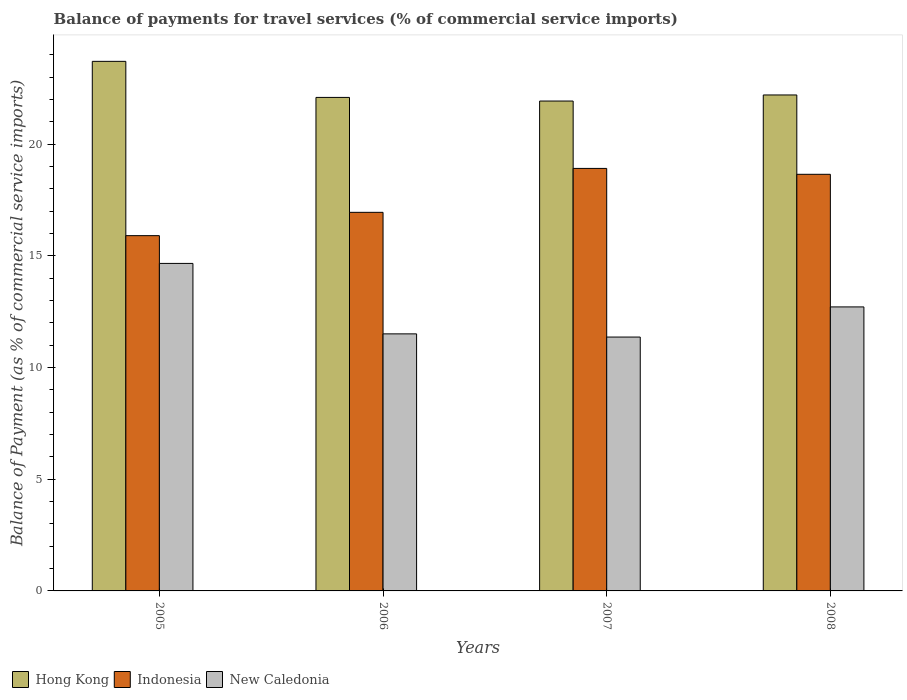How many different coloured bars are there?
Make the answer very short. 3. How many groups of bars are there?
Provide a succinct answer. 4. Are the number of bars per tick equal to the number of legend labels?
Provide a short and direct response. Yes. Are the number of bars on each tick of the X-axis equal?
Offer a very short reply. Yes. What is the label of the 1st group of bars from the left?
Give a very brief answer. 2005. In how many cases, is the number of bars for a given year not equal to the number of legend labels?
Give a very brief answer. 0. What is the balance of payments for travel services in Indonesia in 2005?
Your answer should be very brief. 15.91. Across all years, what is the maximum balance of payments for travel services in Hong Kong?
Your answer should be compact. 23.71. Across all years, what is the minimum balance of payments for travel services in Indonesia?
Offer a very short reply. 15.91. In which year was the balance of payments for travel services in Hong Kong maximum?
Your response must be concise. 2005. What is the total balance of payments for travel services in Indonesia in the graph?
Make the answer very short. 70.43. What is the difference between the balance of payments for travel services in Indonesia in 2005 and that in 2007?
Keep it short and to the point. -3.01. What is the difference between the balance of payments for travel services in New Caledonia in 2008 and the balance of payments for travel services in Indonesia in 2007?
Make the answer very short. -6.2. What is the average balance of payments for travel services in New Caledonia per year?
Your answer should be compact. 12.56. In the year 2008, what is the difference between the balance of payments for travel services in New Caledonia and balance of payments for travel services in Indonesia?
Your answer should be very brief. -5.94. What is the ratio of the balance of payments for travel services in Hong Kong in 2007 to that in 2008?
Offer a very short reply. 0.99. Is the balance of payments for travel services in Indonesia in 2006 less than that in 2008?
Ensure brevity in your answer.  Yes. What is the difference between the highest and the second highest balance of payments for travel services in Hong Kong?
Your answer should be very brief. 1.5. What is the difference between the highest and the lowest balance of payments for travel services in Indonesia?
Give a very brief answer. 3.01. In how many years, is the balance of payments for travel services in New Caledonia greater than the average balance of payments for travel services in New Caledonia taken over all years?
Provide a succinct answer. 2. What does the 2nd bar from the left in 2005 represents?
Offer a terse response. Indonesia. What does the 3rd bar from the right in 2008 represents?
Your answer should be compact. Hong Kong. Is it the case that in every year, the sum of the balance of payments for travel services in Indonesia and balance of payments for travel services in Hong Kong is greater than the balance of payments for travel services in New Caledonia?
Your answer should be very brief. Yes. What is the difference between two consecutive major ticks on the Y-axis?
Provide a succinct answer. 5. Are the values on the major ticks of Y-axis written in scientific E-notation?
Your answer should be very brief. No. Does the graph contain any zero values?
Keep it short and to the point. No. How many legend labels are there?
Your response must be concise. 3. How are the legend labels stacked?
Offer a terse response. Horizontal. What is the title of the graph?
Your answer should be compact. Balance of payments for travel services (% of commercial service imports). What is the label or title of the Y-axis?
Offer a terse response. Balance of Payment (as % of commercial service imports). What is the Balance of Payment (as % of commercial service imports) in Hong Kong in 2005?
Ensure brevity in your answer.  23.71. What is the Balance of Payment (as % of commercial service imports) in Indonesia in 2005?
Your answer should be very brief. 15.91. What is the Balance of Payment (as % of commercial service imports) in New Caledonia in 2005?
Your answer should be very brief. 14.66. What is the Balance of Payment (as % of commercial service imports) of Hong Kong in 2006?
Your answer should be compact. 22.1. What is the Balance of Payment (as % of commercial service imports) in Indonesia in 2006?
Your response must be concise. 16.95. What is the Balance of Payment (as % of commercial service imports) of New Caledonia in 2006?
Keep it short and to the point. 11.51. What is the Balance of Payment (as % of commercial service imports) of Hong Kong in 2007?
Offer a terse response. 21.93. What is the Balance of Payment (as % of commercial service imports) in Indonesia in 2007?
Your response must be concise. 18.92. What is the Balance of Payment (as % of commercial service imports) in New Caledonia in 2007?
Offer a very short reply. 11.37. What is the Balance of Payment (as % of commercial service imports) in Hong Kong in 2008?
Your response must be concise. 22.21. What is the Balance of Payment (as % of commercial service imports) of Indonesia in 2008?
Offer a very short reply. 18.65. What is the Balance of Payment (as % of commercial service imports) in New Caledonia in 2008?
Offer a very short reply. 12.72. Across all years, what is the maximum Balance of Payment (as % of commercial service imports) in Hong Kong?
Give a very brief answer. 23.71. Across all years, what is the maximum Balance of Payment (as % of commercial service imports) of Indonesia?
Offer a very short reply. 18.92. Across all years, what is the maximum Balance of Payment (as % of commercial service imports) in New Caledonia?
Your answer should be very brief. 14.66. Across all years, what is the minimum Balance of Payment (as % of commercial service imports) in Hong Kong?
Provide a succinct answer. 21.93. Across all years, what is the minimum Balance of Payment (as % of commercial service imports) of Indonesia?
Offer a very short reply. 15.91. Across all years, what is the minimum Balance of Payment (as % of commercial service imports) of New Caledonia?
Give a very brief answer. 11.37. What is the total Balance of Payment (as % of commercial service imports) in Hong Kong in the graph?
Offer a very short reply. 89.95. What is the total Balance of Payment (as % of commercial service imports) in Indonesia in the graph?
Your answer should be compact. 70.43. What is the total Balance of Payment (as % of commercial service imports) of New Caledonia in the graph?
Provide a short and direct response. 50.26. What is the difference between the Balance of Payment (as % of commercial service imports) in Hong Kong in 2005 and that in 2006?
Provide a short and direct response. 1.61. What is the difference between the Balance of Payment (as % of commercial service imports) in Indonesia in 2005 and that in 2006?
Provide a succinct answer. -1.04. What is the difference between the Balance of Payment (as % of commercial service imports) in New Caledonia in 2005 and that in 2006?
Your response must be concise. 3.16. What is the difference between the Balance of Payment (as % of commercial service imports) in Hong Kong in 2005 and that in 2007?
Your response must be concise. 1.78. What is the difference between the Balance of Payment (as % of commercial service imports) in Indonesia in 2005 and that in 2007?
Your response must be concise. -3.01. What is the difference between the Balance of Payment (as % of commercial service imports) of New Caledonia in 2005 and that in 2007?
Make the answer very short. 3.3. What is the difference between the Balance of Payment (as % of commercial service imports) of Hong Kong in 2005 and that in 2008?
Provide a short and direct response. 1.5. What is the difference between the Balance of Payment (as % of commercial service imports) in Indonesia in 2005 and that in 2008?
Provide a short and direct response. -2.75. What is the difference between the Balance of Payment (as % of commercial service imports) in New Caledonia in 2005 and that in 2008?
Ensure brevity in your answer.  1.95. What is the difference between the Balance of Payment (as % of commercial service imports) in Hong Kong in 2006 and that in 2007?
Your answer should be very brief. 0.16. What is the difference between the Balance of Payment (as % of commercial service imports) of Indonesia in 2006 and that in 2007?
Offer a terse response. -1.97. What is the difference between the Balance of Payment (as % of commercial service imports) of New Caledonia in 2006 and that in 2007?
Your response must be concise. 0.14. What is the difference between the Balance of Payment (as % of commercial service imports) in Hong Kong in 2006 and that in 2008?
Your answer should be very brief. -0.11. What is the difference between the Balance of Payment (as % of commercial service imports) of Indonesia in 2006 and that in 2008?
Your answer should be compact. -1.7. What is the difference between the Balance of Payment (as % of commercial service imports) in New Caledonia in 2006 and that in 2008?
Provide a short and direct response. -1.21. What is the difference between the Balance of Payment (as % of commercial service imports) in Hong Kong in 2007 and that in 2008?
Keep it short and to the point. -0.27. What is the difference between the Balance of Payment (as % of commercial service imports) in Indonesia in 2007 and that in 2008?
Your response must be concise. 0.26. What is the difference between the Balance of Payment (as % of commercial service imports) of New Caledonia in 2007 and that in 2008?
Your answer should be very brief. -1.35. What is the difference between the Balance of Payment (as % of commercial service imports) in Hong Kong in 2005 and the Balance of Payment (as % of commercial service imports) in Indonesia in 2006?
Keep it short and to the point. 6.76. What is the difference between the Balance of Payment (as % of commercial service imports) of Hong Kong in 2005 and the Balance of Payment (as % of commercial service imports) of New Caledonia in 2006?
Your response must be concise. 12.2. What is the difference between the Balance of Payment (as % of commercial service imports) of Indonesia in 2005 and the Balance of Payment (as % of commercial service imports) of New Caledonia in 2006?
Your answer should be very brief. 4.4. What is the difference between the Balance of Payment (as % of commercial service imports) of Hong Kong in 2005 and the Balance of Payment (as % of commercial service imports) of Indonesia in 2007?
Make the answer very short. 4.79. What is the difference between the Balance of Payment (as % of commercial service imports) in Hong Kong in 2005 and the Balance of Payment (as % of commercial service imports) in New Caledonia in 2007?
Keep it short and to the point. 12.34. What is the difference between the Balance of Payment (as % of commercial service imports) in Indonesia in 2005 and the Balance of Payment (as % of commercial service imports) in New Caledonia in 2007?
Keep it short and to the point. 4.54. What is the difference between the Balance of Payment (as % of commercial service imports) in Hong Kong in 2005 and the Balance of Payment (as % of commercial service imports) in Indonesia in 2008?
Your response must be concise. 5.06. What is the difference between the Balance of Payment (as % of commercial service imports) in Hong Kong in 2005 and the Balance of Payment (as % of commercial service imports) in New Caledonia in 2008?
Offer a very short reply. 11. What is the difference between the Balance of Payment (as % of commercial service imports) of Indonesia in 2005 and the Balance of Payment (as % of commercial service imports) of New Caledonia in 2008?
Provide a short and direct response. 3.19. What is the difference between the Balance of Payment (as % of commercial service imports) of Hong Kong in 2006 and the Balance of Payment (as % of commercial service imports) of Indonesia in 2007?
Offer a very short reply. 3.18. What is the difference between the Balance of Payment (as % of commercial service imports) of Hong Kong in 2006 and the Balance of Payment (as % of commercial service imports) of New Caledonia in 2007?
Your answer should be compact. 10.73. What is the difference between the Balance of Payment (as % of commercial service imports) in Indonesia in 2006 and the Balance of Payment (as % of commercial service imports) in New Caledonia in 2007?
Your answer should be compact. 5.58. What is the difference between the Balance of Payment (as % of commercial service imports) of Hong Kong in 2006 and the Balance of Payment (as % of commercial service imports) of Indonesia in 2008?
Make the answer very short. 3.44. What is the difference between the Balance of Payment (as % of commercial service imports) of Hong Kong in 2006 and the Balance of Payment (as % of commercial service imports) of New Caledonia in 2008?
Your answer should be compact. 9.38. What is the difference between the Balance of Payment (as % of commercial service imports) of Indonesia in 2006 and the Balance of Payment (as % of commercial service imports) of New Caledonia in 2008?
Provide a succinct answer. 4.23. What is the difference between the Balance of Payment (as % of commercial service imports) in Hong Kong in 2007 and the Balance of Payment (as % of commercial service imports) in Indonesia in 2008?
Ensure brevity in your answer.  3.28. What is the difference between the Balance of Payment (as % of commercial service imports) of Hong Kong in 2007 and the Balance of Payment (as % of commercial service imports) of New Caledonia in 2008?
Make the answer very short. 9.22. What is the difference between the Balance of Payment (as % of commercial service imports) of Indonesia in 2007 and the Balance of Payment (as % of commercial service imports) of New Caledonia in 2008?
Ensure brevity in your answer.  6.2. What is the average Balance of Payment (as % of commercial service imports) in Hong Kong per year?
Your answer should be compact. 22.49. What is the average Balance of Payment (as % of commercial service imports) in Indonesia per year?
Your response must be concise. 17.61. What is the average Balance of Payment (as % of commercial service imports) of New Caledonia per year?
Offer a very short reply. 12.56. In the year 2005, what is the difference between the Balance of Payment (as % of commercial service imports) of Hong Kong and Balance of Payment (as % of commercial service imports) of Indonesia?
Your answer should be very brief. 7.8. In the year 2005, what is the difference between the Balance of Payment (as % of commercial service imports) in Hong Kong and Balance of Payment (as % of commercial service imports) in New Caledonia?
Give a very brief answer. 9.05. In the year 2005, what is the difference between the Balance of Payment (as % of commercial service imports) of Indonesia and Balance of Payment (as % of commercial service imports) of New Caledonia?
Offer a terse response. 1.24. In the year 2006, what is the difference between the Balance of Payment (as % of commercial service imports) of Hong Kong and Balance of Payment (as % of commercial service imports) of Indonesia?
Provide a short and direct response. 5.15. In the year 2006, what is the difference between the Balance of Payment (as % of commercial service imports) of Hong Kong and Balance of Payment (as % of commercial service imports) of New Caledonia?
Provide a short and direct response. 10.59. In the year 2006, what is the difference between the Balance of Payment (as % of commercial service imports) of Indonesia and Balance of Payment (as % of commercial service imports) of New Caledonia?
Make the answer very short. 5.44. In the year 2007, what is the difference between the Balance of Payment (as % of commercial service imports) in Hong Kong and Balance of Payment (as % of commercial service imports) in Indonesia?
Your answer should be compact. 3.02. In the year 2007, what is the difference between the Balance of Payment (as % of commercial service imports) in Hong Kong and Balance of Payment (as % of commercial service imports) in New Caledonia?
Ensure brevity in your answer.  10.57. In the year 2007, what is the difference between the Balance of Payment (as % of commercial service imports) of Indonesia and Balance of Payment (as % of commercial service imports) of New Caledonia?
Provide a succinct answer. 7.55. In the year 2008, what is the difference between the Balance of Payment (as % of commercial service imports) in Hong Kong and Balance of Payment (as % of commercial service imports) in Indonesia?
Your response must be concise. 3.55. In the year 2008, what is the difference between the Balance of Payment (as % of commercial service imports) of Hong Kong and Balance of Payment (as % of commercial service imports) of New Caledonia?
Give a very brief answer. 9.49. In the year 2008, what is the difference between the Balance of Payment (as % of commercial service imports) in Indonesia and Balance of Payment (as % of commercial service imports) in New Caledonia?
Provide a succinct answer. 5.94. What is the ratio of the Balance of Payment (as % of commercial service imports) of Hong Kong in 2005 to that in 2006?
Offer a very short reply. 1.07. What is the ratio of the Balance of Payment (as % of commercial service imports) in Indonesia in 2005 to that in 2006?
Your answer should be very brief. 0.94. What is the ratio of the Balance of Payment (as % of commercial service imports) in New Caledonia in 2005 to that in 2006?
Offer a terse response. 1.27. What is the ratio of the Balance of Payment (as % of commercial service imports) of Hong Kong in 2005 to that in 2007?
Ensure brevity in your answer.  1.08. What is the ratio of the Balance of Payment (as % of commercial service imports) of Indonesia in 2005 to that in 2007?
Provide a succinct answer. 0.84. What is the ratio of the Balance of Payment (as % of commercial service imports) of New Caledonia in 2005 to that in 2007?
Offer a terse response. 1.29. What is the ratio of the Balance of Payment (as % of commercial service imports) in Hong Kong in 2005 to that in 2008?
Ensure brevity in your answer.  1.07. What is the ratio of the Balance of Payment (as % of commercial service imports) of Indonesia in 2005 to that in 2008?
Your answer should be compact. 0.85. What is the ratio of the Balance of Payment (as % of commercial service imports) of New Caledonia in 2005 to that in 2008?
Give a very brief answer. 1.15. What is the ratio of the Balance of Payment (as % of commercial service imports) in Hong Kong in 2006 to that in 2007?
Make the answer very short. 1.01. What is the ratio of the Balance of Payment (as % of commercial service imports) in Indonesia in 2006 to that in 2007?
Your response must be concise. 0.9. What is the ratio of the Balance of Payment (as % of commercial service imports) of New Caledonia in 2006 to that in 2007?
Ensure brevity in your answer.  1.01. What is the ratio of the Balance of Payment (as % of commercial service imports) of Hong Kong in 2006 to that in 2008?
Make the answer very short. 1. What is the ratio of the Balance of Payment (as % of commercial service imports) in Indonesia in 2006 to that in 2008?
Keep it short and to the point. 0.91. What is the ratio of the Balance of Payment (as % of commercial service imports) in New Caledonia in 2006 to that in 2008?
Offer a terse response. 0.91. What is the ratio of the Balance of Payment (as % of commercial service imports) of Indonesia in 2007 to that in 2008?
Provide a succinct answer. 1.01. What is the ratio of the Balance of Payment (as % of commercial service imports) in New Caledonia in 2007 to that in 2008?
Your response must be concise. 0.89. What is the difference between the highest and the second highest Balance of Payment (as % of commercial service imports) of Hong Kong?
Make the answer very short. 1.5. What is the difference between the highest and the second highest Balance of Payment (as % of commercial service imports) in Indonesia?
Ensure brevity in your answer.  0.26. What is the difference between the highest and the second highest Balance of Payment (as % of commercial service imports) of New Caledonia?
Your response must be concise. 1.95. What is the difference between the highest and the lowest Balance of Payment (as % of commercial service imports) in Hong Kong?
Provide a succinct answer. 1.78. What is the difference between the highest and the lowest Balance of Payment (as % of commercial service imports) of Indonesia?
Your answer should be very brief. 3.01. What is the difference between the highest and the lowest Balance of Payment (as % of commercial service imports) in New Caledonia?
Provide a succinct answer. 3.3. 